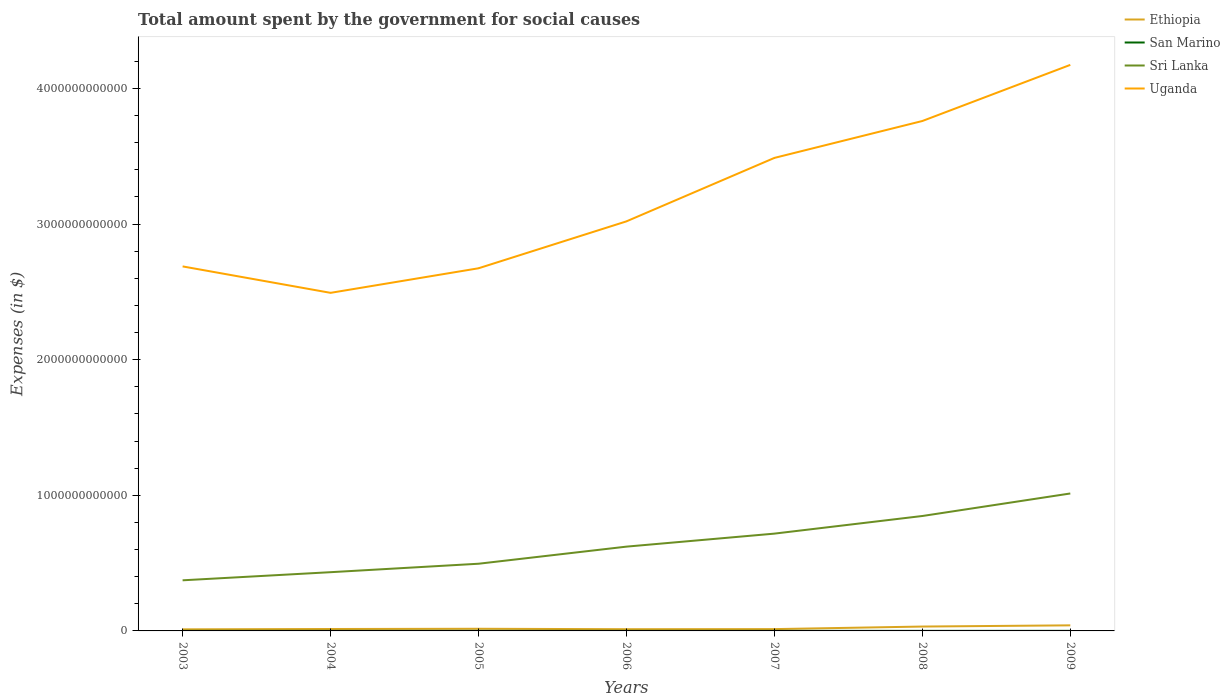Does the line corresponding to Sri Lanka intersect with the line corresponding to Ethiopia?
Give a very brief answer. No. Is the number of lines equal to the number of legend labels?
Provide a succinct answer. Yes. Across all years, what is the maximum amount spent for social causes by the government in Uganda?
Make the answer very short. 2.49e+12. In which year was the amount spent for social causes by the government in San Marino maximum?
Provide a succinct answer. 2003. What is the total amount spent for social causes by the government in Uganda in the graph?
Provide a short and direct response. -1.27e+12. What is the difference between the highest and the second highest amount spent for social causes by the government in Sri Lanka?
Ensure brevity in your answer.  6.40e+11. What is the difference between the highest and the lowest amount spent for social causes by the government in Ethiopia?
Offer a terse response. 2. How many lines are there?
Give a very brief answer. 4. What is the difference between two consecutive major ticks on the Y-axis?
Provide a succinct answer. 1.00e+12. Are the values on the major ticks of Y-axis written in scientific E-notation?
Provide a succinct answer. No. Does the graph contain grids?
Your response must be concise. No. Where does the legend appear in the graph?
Provide a short and direct response. Top right. How many legend labels are there?
Provide a short and direct response. 4. How are the legend labels stacked?
Keep it short and to the point. Vertical. What is the title of the graph?
Keep it short and to the point. Total amount spent by the government for social causes. What is the label or title of the X-axis?
Provide a succinct answer. Years. What is the label or title of the Y-axis?
Your response must be concise. Expenses (in $). What is the Expenses (in $) in Ethiopia in 2003?
Make the answer very short. 1.17e+1. What is the Expenses (in $) in San Marino in 2003?
Your response must be concise. 4.07e+08. What is the Expenses (in $) in Sri Lanka in 2003?
Provide a succinct answer. 3.73e+11. What is the Expenses (in $) of Uganda in 2003?
Give a very brief answer. 2.69e+12. What is the Expenses (in $) in Ethiopia in 2004?
Your answer should be very brief. 1.41e+1. What is the Expenses (in $) in San Marino in 2004?
Keep it short and to the point. 4.59e+08. What is the Expenses (in $) of Sri Lanka in 2004?
Offer a terse response. 4.33e+11. What is the Expenses (in $) of Uganda in 2004?
Provide a short and direct response. 2.49e+12. What is the Expenses (in $) of Ethiopia in 2005?
Provide a succinct answer. 1.59e+1. What is the Expenses (in $) of San Marino in 2005?
Offer a terse response. 4.33e+08. What is the Expenses (in $) in Sri Lanka in 2005?
Your response must be concise. 4.95e+11. What is the Expenses (in $) of Uganda in 2005?
Provide a succinct answer. 2.67e+12. What is the Expenses (in $) of Ethiopia in 2006?
Keep it short and to the point. 1.26e+1. What is the Expenses (in $) of San Marino in 2006?
Give a very brief answer. 4.46e+08. What is the Expenses (in $) in Sri Lanka in 2006?
Provide a succinct answer. 6.21e+11. What is the Expenses (in $) of Uganda in 2006?
Your answer should be compact. 3.02e+12. What is the Expenses (in $) in Ethiopia in 2007?
Give a very brief answer. 1.33e+1. What is the Expenses (in $) of San Marino in 2007?
Your answer should be very brief. 4.86e+08. What is the Expenses (in $) of Sri Lanka in 2007?
Provide a succinct answer. 7.17e+11. What is the Expenses (in $) of Uganda in 2007?
Make the answer very short. 3.49e+12. What is the Expenses (in $) of Ethiopia in 2008?
Your response must be concise. 3.22e+1. What is the Expenses (in $) in San Marino in 2008?
Provide a short and direct response. 5.02e+08. What is the Expenses (in $) of Sri Lanka in 2008?
Offer a terse response. 8.47e+11. What is the Expenses (in $) of Uganda in 2008?
Keep it short and to the point. 3.76e+12. What is the Expenses (in $) in Ethiopia in 2009?
Your answer should be very brief. 4.11e+1. What is the Expenses (in $) in San Marino in 2009?
Provide a short and direct response. 5.34e+08. What is the Expenses (in $) in Sri Lanka in 2009?
Your answer should be compact. 1.01e+12. What is the Expenses (in $) in Uganda in 2009?
Your response must be concise. 4.17e+12. Across all years, what is the maximum Expenses (in $) of Ethiopia?
Your response must be concise. 4.11e+1. Across all years, what is the maximum Expenses (in $) in San Marino?
Offer a terse response. 5.34e+08. Across all years, what is the maximum Expenses (in $) in Sri Lanka?
Your response must be concise. 1.01e+12. Across all years, what is the maximum Expenses (in $) of Uganda?
Your response must be concise. 4.17e+12. Across all years, what is the minimum Expenses (in $) of Ethiopia?
Make the answer very short. 1.17e+1. Across all years, what is the minimum Expenses (in $) in San Marino?
Your answer should be very brief. 4.07e+08. Across all years, what is the minimum Expenses (in $) in Sri Lanka?
Give a very brief answer. 3.73e+11. Across all years, what is the minimum Expenses (in $) of Uganda?
Make the answer very short. 2.49e+12. What is the total Expenses (in $) of Ethiopia in the graph?
Ensure brevity in your answer.  1.41e+11. What is the total Expenses (in $) in San Marino in the graph?
Offer a very short reply. 3.27e+09. What is the total Expenses (in $) in Sri Lanka in the graph?
Give a very brief answer. 4.50e+12. What is the total Expenses (in $) of Uganda in the graph?
Provide a succinct answer. 2.23e+13. What is the difference between the Expenses (in $) in Ethiopia in 2003 and that in 2004?
Your answer should be compact. -2.45e+09. What is the difference between the Expenses (in $) in San Marino in 2003 and that in 2004?
Offer a terse response. -5.16e+07. What is the difference between the Expenses (in $) of Sri Lanka in 2003 and that in 2004?
Offer a terse response. -5.98e+1. What is the difference between the Expenses (in $) of Uganda in 2003 and that in 2004?
Give a very brief answer. 1.95e+11. What is the difference between the Expenses (in $) of Ethiopia in 2003 and that in 2005?
Your answer should be compact. -4.27e+09. What is the difference between the Expenses (in $) of San Marino in 2003 and that in 2005?
Offer a very short reply. -2.59e+07. What is the difference between the Expenses (in $) of Sri Lanka in 2003 and that in 2005?
Your answer should be compact. -1.22e+11. What is the difference between the Expenses (in $) in Uganda in 2003 and that in 2005?
Your answer should be very brief. 1.39e+1. What is the difference between the Expenses (in $) in Ethiopia in 2003 and that in 2006?
Make the answer very short. -9.59e+08. What is the difference between the Expenses (in $) in San Marino in 2003 and that in 2006?
Provide a short and direct response. -3.85e+07. What is the difference between the Expenses (in $) of Sri Lanka in 2003 and that in 2006?
Offer a very short reply. -2.48e+11. What is the difference between the Expenses (in $) of Uganda in 2003 and that in 2006?
Offer a terse response. -3.32e+11. What is the difference between the Expenses (in $) of Ethiopia in 2003 and that in 2007?
Provide a short and direct response. -1.67e+09. What is the difference between the Expenses (in $) of San Marino in 2003 and that in 2007?
Make the answer very short. -7.90e+07. What is the difference between the Expenses (in $) of Sri Lanka in 2003 and that in 2007?
Keep it short and to the point. -3.44e+11. What is the difference between the Expenses (in $) in Uganda in 2003 and that in 2007?
Provide a succinct answer. -8.00e+11. What is the difference between the Expenses (in $) of Ethiopia in 2003 and that in 2008?
Your response must be concise. -2.06e+1. What is the difference between the Expenses (in $) in San Marino in 2003 and that in 2008?
Ensure brevity in your answer.  -9.46e+07. What is the difference between the Expenses (in $) of Sri Lanka in 2003 and that in 2008?
Provide a succinct answer. -4.74e+11. What is the difference between the Expenses (in $) in Uganda in 2003 and that in 2008?
Keep it short and to the point. -1.07e+12. What is the difference between the Expenses (in $) of Ethiopia in 2003 and that in 2009?
Give a very brief answer. -2.94e+1. What is the difference between the Expenses (in $) of San Marino in 2003 and that in 2009?
Keep it short and to the point. -1.27e+08. What is the difference between the Expenses (in $) in Sri Lanka in 2003 and that in 2009?
Your answer should be compact. -6.40e+11. What is the difference between the Expenses (in $) in Uganda in 2003 and that in 2009?
Make the answer very short. -1.49e+12. What is the difference between the Expenses (in $) in Ethiopia in 2004 and that in 2005?
Your answer should be compact. -1.82e+09. What is the difference between the Expenses (in $) of San Marino in 2004 and that in 2005?
Your response must be concise. 2.57e+07. What is the difference between the Expenses (in $) in Sri Lanka in 2004 and that in 2005?
Provide a succinct answer. -6.23e+1. What is the difference between the Expenses (in $) of Uganda in 2004 and that in 2005?
Offer a very short reply. -1.81e+11. What is the difference between the Expenses (in $) of Ethiopia in 2004 and that in 2006?
Provide a short and direct response. 1.50e+09. What is the difference between the Expenses (in $) in San Marino in 2004 and that in 2006?
Offer a terse response. 1.31e+07. What is the difference between the Expenses (in $) in Sri Lanka in 2004 and that in 2006?
Make the answer very short. -1.88e+11. What is the difference between the Expenses (in $) in Uganda in 2004 and that in 2006?
Give a very brief answer. -5.27e+11. What is the difference between the Expenses (in $) in Ethiopia in 2004 and that in 2007?
Give a very brief answer. 7.85e+08. What is the difference between the Expenses (in $) in San Marino in 2004 and that in 2007?
Your answer should be compact. -2.74e+07. What is the difference between the Expenses (in $) in Sri Lanka in 2004 and that in 2007?
Ensure brevity in your answer.  -2.84e+11. What is the difference between the Expenses (in $) in Uganda in 2004 and that in 2007?
Give a very brief answer. -9.95e+11. What is the difference between the Expenses (in $) of Ethiopia in 2004 and that in 2008?
Ensure brevity in your answer.  -1.81e+1. What is the difference between the Expenses (in $) in San Marino in 2004 and that in 2008?
Give a very brief answer. -4.31e+07. What is the difference between the Expenses (in $) in Sri Lanka in 2004 and that in 2008?
Your answer should be compact. -4.14e+11. What is the difference between the Expenses (in $) in Uganda in 2004 and that in 2008?
Offer a very short reply. -1.27e+12. What is the difference between the Expenses (in $) of Ethiopia in 2004 and that in 2009?
Provide a short and direct response. -2.70e+1. What is the difference between the Expenses (in $) of San Marino in 2004 and that in 2009?
Your answer should be compact. -7.51e+07. What is the difference between the Expenses (in $) in Sri Lanka in 2004 and that in 2009?
Your response must be concise. -5.80e+11. What is the difference between the Expenses (in $) of Uganda in 2004 and that in 2009?
Your response must be concise. -1.68e+12. What is the difference between the Expenses (in $) of Ethiopia in 2005 and that in 2006?
Give a very brief answer. 3.31e+09. What is the difference between the Expenses (in $) in San Marino in 2005 and that in 2006?
Keep it short and to the point. -1.26e+07. What is the difference between the Expenses (in $) in Sri Lanka in 2005 and that in 2006?
Make the answer very short. -1.26e+11. What is the difference between the Expenses (in $) of Uganda in 2005 and that in 2006?
Give a very brief answer. -3.46e+11. What is the difference between the Expenses (in $) in Ethiopia in 2005 and that in 2007?
Your answer should be compact. 2.60e+09. What is the difference between the Expenses (in $) of San Marino in 2005 and that in 2007?
Give a very brief answer. -5.31e+07. What is the difference between the Expenses (in $) in Sri Lanka in 2005 and that in 2007?
Provide a short and direct response. -2.22e+11. What is the difference between the Expenses (in $) of Uganda in 2005 and that in 2007?
Your answer should be compact. -8.14e+11. What is the difference between the Expenses (in $) of Ethiopia in 2005 and that in 2008?
Your answer should be compact. -1.63e+1. What is the difference between the Expenses (in $) in San Marino in 2005 and that in 2008?
Give a very brief answer. -6.88e+07. What is the difference between the Expenses (in $) in Sri Lanka in 2005 and that in 2008?
Provide a short and direct response. -3.52e+11. What is the difference between the Expenses (in $) in Uganda in 2005 and that in 2008?
Offer a very short reply. -1.09e+12. What is the difference between the Expenses (in $) of Ethiopia in 2005 and that in 2009?
Give a very brief answer. -2.51e+1. What is the difference between the Expenses (in $) in San Marino in 2005 and that in 2009?
Provide a short and direct response. -1.01e+08. What is the difference between the Expenses (in $) in Sri Lanka in 2005 and that in 2009?
Provide a succinct answer. -5.18e+11. What is the difference between the Expenses (in $) of Uganda in 2005 and that in 2009?
Your response must be concise. -1.50e+12. What is the difference between the Expenses (in $) of Ethiopia in 2006 and that in 2007?
Ensure brevity in your answer.  -7.10e+08. What is the difference between the Expenses (in $) in San Marino in 2006 and that in 2007?
Give a very brief answer. -4.05e+07. What is the difference between the Expenses (in $) in Sri Lanka in 2006 and that in 2007?
Offer a very short reply. -9.59e+1. What is the difference between the Expenses (in $) in Uganda in 2006 and that in 2007?
Ensure brevity in your answer.  -4.68e+11. What is the difference between the Expenses (in $) of Ethiopia in 2006 and that in 2008?
Provide a short and direct response. -1.96e+1. What is the difference between the Expenses (in $) of San Marino in 2006 and that in 2008?
Keep it short and to the point. -5.62e+07. What is the difference between the Expenses (in $) in Sri Lanka in 2006 and that in 2008?
Keep it short and to the point. -2.26e+11. What is the difference between the Expenses (in $) in Uganda in 2006 and that in 2008?
Give a very brief answer. -7.40e+11. What is the difference between the Expenses (in $) in Ethiopia in 2006 and that in 2009?
Make the answer very short. -2.85e+1. What is the difference between the Expenses (in $) in San Marino in 2006 and that in 2009?
Your response must be concise. -8.82e+07. What is the difference between the Expenses (in $) in Sri Lanka in 2006 and that in 2009?
Provide a succinct answer. -3.92e+11. What is the difference between the Expenses (in $) of Uganda in 2006 and that in 2009?
Ensure brevity in your answer.  -1.15e+12. What is the difference between the Expenses (in $) of Ethiopia in 2007 and that in 2008?
Provide a succinct answer. -1.89e+1. What is the difference between the Expenses (in $) of San Marino in 2007 and that in 2008?
Provide a short and direct response. -1.57e+07. What is the difference between the Expenses (in $) of Sri Lanka in 2007 and that in 2008?
Offer a very short reply. -1.30e+11. What is the difference between the Expenses (in $) in Uganda in 2007 and that in 2008?
Make the answer very short. -2.72e+11. What is the difference between the Expenses (in $) in Ethiopia in 2007 and that in 2009?
Provide a short and direct response. -2.77e+1. What is the difference between the Expenses (in $) of San Marino in 2007 and that in 2009?
Your answer should be very brief. -4.77e+07. What is the difference between the Expenses (in $) of Sri Lanka in 2007 and that in 2009?
Your response must be concise. -2.96e+11. What is the difference between the Expenses (in $) in Uganda in 2007 and that in 2009?
Ensure brevity in your answer.  -6.86e+11. What is the difference between the Expenses (in $) of Ethiopia in 2008 and that in 2009?
Give a very brief answer. -8.85e+09. What is the difference between the Expenses (in $) in San Marino in 2008 and that in 2009?
Provide a succinct answer. -3.20e+07. What is the difference between the Expenses (in $) of Sri Lanka in 2008 and that in 2009?
Provide a succinct answer. -1.66e+11. What is the difference between the Expenses (in $) in Uganda in 2008 and that in 2009?
Give a very brief answer. -4.14e+11. What is the difference between the Expenses (in $) of Ethiopia in 2003 and the Expenses (in $) of San Marino in 2004?
Offer a terse response. 1.12e+1. What is the difference between the Expenses (in $) in Ethiopia in 2003 and the Expenses (in $) in Sri Lanka in 2004?
Your answer should be very brief. -4.21e+11. What is the difference between the Expenses (in $) in Ethiopia in 2003 and the Expenses (in $) in Uganda in 2004?
Your answer should be very brief. -2.48e+12. What is the difference between the Expenses (in $) of San Marino in 2003 and the Expenses (in $) of Sri Lanka in 2004?
Offer a terse response. -4.33e+11. What is the difference between the Expenses (in $) in San Marino in 2003 and the Expenses (in $) in Uganda in 2004?
Give a very brief answer. -2.49e+12. What is the difference between the Expenses (in $) of Sri Lanka in 2003 and the Expenses (in $) of Uganda in 2004?
Your response must be concise. -2.12e+12. What is the difference between the Expenses (in $) in Ethiopia in 2003 and the Expenses (in $) in San Marino in 2005?
Provide a short and direct response. 1.12e+1. What is the difference between the Expenses (in $) in Ethiopia in 2003 and the Expenses (in $) in Sri Lanka in 2005?
Provide a succinct answer. -4.84e+11. What is the difference between the Expenses (in $) of Ethiopia in 2003 and the Expenses (in $) of Uganda in 2005?
Offer a very short reply. -2.66e+12. What is the difference between the Expenses (in $) of San Marino in 2003 and the Expenses (in $) of Sri Lanka in 2005?
Your answer should be compact. -4.95e+11. What is the difference between the Expenses (in $) of San Marino in 2003 and the Expenses (in $) of Uganda in 2005?
Ensure brevity in your answer.  -2.67e+12. What is the difference between the Expenses (in $) in Sri Lanka in 2003 and the Expenses (in $) in Uganda in 2005?
Offer a terse response. -2.30e+12. What is the difference between the Expenses (in $) of Ethiopia in 2003 and the Expenses (in $) of San Marino in 2006?
Your answer should be very brief. 1.12e+1. What is the difference between the Expenses (in $) of Ethiopia in 2003 and the Expenses (in $) of Sri Lanka in 2006?
Provide a short and direct response. -6.10e+11. What is the difference between the Expenses (in $) of Ethiopia in 2003 and the Expenses (in $) of Uganda in 2006?
Provide a succinct answer. -3.01e+12. What is the difference between the Expenses (in $) of San Marino in 2003 and the Expenses (in $) of Sri Lanka in 2006?
Keep it short and to the point. -6.21e+11. What is the difference between the Expenses (in $) in San Marino in 2003 and the Expenses (in $) in Uganda in 2006?
Your answer should be compact. -3.02e+12. What is the difference between the Expenses (in $) of Sri Lanka in 2003 and the Expenses (in $) of Uganda in 2006?
Provide a succinct answer. -2.65e+12. What is the difference between the Expenses (in $) of Ethiopia in 2003 and the Expenses (in $) of San Marino in 2007?
Make the answer very short. 1.12e+1. What is the difference between the Expenses (in $) of Ethiopia in 2003 and the Expenses (in $) of Sri Lanka in 2007?
Keep it short and to the point. -7.06e+11. What is the difference between the Expenses (in $) of Ethiopia in 2003 and the Expenses (in $) of Uganda in 2007?
Provide a succinct answer. -3.48e+12. What is the difference between the Expenses (in $) in San Marino in 2003 and the Expenses (in $) in Sri Lanka in 2007?
Keep it short and to the point. -7.17e+11. What is the difference between the Expenses (in $) in San Marino in 2003 and the Expenses (in $) in Uganda in 2007?
Keep it short and to the point. -3.49e+12. What is the difference between the Expenses (in $) in Sri Lanka in 2003 and the Expenses (in $) in Uganda in 2007?
Give a very brief answer. -3.11e+12. What is the difference between the Expenses (in $) of Ethiopia in 2003 and the Expenses (in $) of San Marino in 2008?
Give a very brief answer. 1.12e+1. What is the difference between the Expenses (in $) in Ethiopia in 2003 and the Expenses (in $) in Sri Lanka in 2008?
Keep it short and to the point. -8.36e+11. What is the difference between the Expenses (in $) in Ethiopia in 2003 and the Expenses (in $) in Uganda in 2008?
Offer a very short reply. -3.75e+12. What is the difference between the Expenses (in $) in San Marino in 2003 and the Expenses (in $) in Sri Lanka in 2008?
Your answer should be compact. -8.47e+11. What is the difference between the Expenses (in $) of San Marino in 2003 and the Expenses (in $) of Uganda in 2008?
Offer a very short reply. -3.76e+12. What is the difference between the Expenses (in $) in Sri Lanka in 2003 and the Expenses (in $) in Uganda in 2008?
Keep it short and to the point. -3.39e+12. What is the difference between the Expenses (in $) in Ethiopia in 2003 and the Expenses (in $) in San Marino in 2009?
Offer a very short reply. 1.11e+1. What is the difference between the Expenses (in $) of Ethiopia in 2003 and the Expenses (in $) of Sri Lanka in 2009?
Your response must be concise. -1.00e+12. What is the difference between the Expenses (in $) in Ethiopia in 2003 and the Expenses (in $) in Uganda in 2009?
Provide a succinct answer. -4.16e+12. What is the difference between the Expenses (in $) of San Marino in 2003 and the Expenses (in $) of Sri Lanka in 2009?
Ensure brevity in your answer.  -1.01e+12. What is the difference between the Expenses (in $) of San Marino in 2003 and the Expenses (in $) of Uganda in 2009?
Your response must be concise. -4.17e+12. What is the difference between the Expenses (in $) in Sri Lanka in 2003 and the Expenses (in $) in Uganda in 2009?
Provide a short and direct response. -3.80e+12. What is the difference between the Expenses (in $) of Ethiopia in 2004 and the Expenses (in $) of San Marino in 2005?
Offer a very short reply. 1.37e+1. What is the difference between the Expenses (in $) in Ethiopia in 2004 and the Expenses (in $) in Sri Lanka in 2005?
Your response must be concise. -4.81e+11. What is the difference between the Expenses (in $) of Ethiopia in 2004 and the Expenses (in $) of Uganda in 2005?
Keep it short and to the point. -2.66e+12. What is the difference between the Expenses (in $) of San Marino in 2004 and the Expenses (in $) of Sri Lanka in 2005?
Your answer should be compact. -4.95e+11. What is the difference between the Expenses (in $) in San Marino in 2004 and the Expenses (in $) in Uganda in 2005?
Provide a succinct answer. -2.67e+12. What is the difference between the Expenses (in $) of Sri Lanka in 2004 and the Expenses (in $) of Uganda in 2005?
Keep it short and to the point. -2.24e+12. What is the difference between the Expenses (in $) of Ethiopia in 2004 and the Expenses (in $) of San Marino in 2006?
Ensure brevity in your answer.  1.37e+1. What is the difference between the Expenses (in $) of Ethiopia in 2004 and the Expenses (in $) of Sri Lanka in 2006?
Offer a very short reply. -6.07e+11. What is the difference between the Expenses (in $) of Ethiopia in 2004 and the Expenses (in $) of Uganda in 2006?
Provide a succinct answer. -3.01e+12. What is the difference between the Expenses (in $) in San Marino in 2004 and the Expenses (in $) in Sri Lanka in 2006?
Give a very brief answer. -6.21e+11. What is the difference between the Expenses (in $) of San Marino in 2004 and the Expenses (in $) of Uganda in 2006?
Ensure brevity in your answer.  -3.02e+12. What is the difference between the Expenses (in $) in Sri Lanka in 2004 and the Expenses (in $) in Uganda in 2006?
Your answer should be compact. -2.59e+12. What is the difference between the Expenses (in $) of Ethiopia in 2004 and the Expenses (in $) of San Marino in 2007?
Ensure brevity in your answer.  1.36e+1. What is the difference between the Expenses (in $) in Ethiopia in 2004 and the Expenses (in $) in Sri Lanka in 2007?
Your response must be concise. -7.03e+11. What is the difference between the Expenses (in $) in Ethiopia in 2004 and the Expenses (in $) in Uganda in 2007?
Your answer should be very brief. -3.47e+12. What is the difference between the Expenses (in $) of San Marino in 2004 and the Expenses (in $) of Sri Lanka in 2007?
Keep it short and to the point. -7.17e+11. What is the difference between the Expenses (in $) of San Marino in 2004 and the Expenses (in $) of Uganda in 2007?
Your response must be concise. -3.49e+12. What is the difference between the Expenses (in $) in Sri Lanka in 2004 and the Expenses (in $) in Uganda in 2007?
Ensure brevity in your answer.  -3.05e+12. What is the difference between the Expenses (in $) of Ethiopia in 2004 and the Expenses (in $) of San Marino in 2008?
Ensure brevity in your answer.  1.36e+1. What is the difference between the Expenses (in $) in Ethiopia in 2004 and the Expenses (in $) in Sri Lanka in 2008?
Offer a very short reply. -8.33e+11. What is the difference between the Expenses (in $) in Ethiopia in 2004 and the Expenses (in $) in Uganda in 2008?
Offer a very short reply. -3.75e+12. What is the difference between the Expenses (in $) in San Marino in 2004 and the Expenses (in $) in Sri Lanka in 2008?
Your answer should be very brief. -8.47e+11. What is the difference between the Expenses (in $) of San Marino in 2004 and the Expenses (in $) of Uganda in 2008?
Your answer should be very brief. -3.76e+12. What is the difference between the Expenses (in $) of Sri Lanka in 2004 and the Expenses (in $) of Uganda in 2008?
Give a very brief answer. -3.33e+12. What is the difference between the Expenses (in $) of Ethiopia in 2004 and the Expenses (in $) of San Marino in 2009?
Your response must be concise. 1.36e+1. What is the difference between the Expenses (in $) of Ethiopia in 2004 and the Expenses (in $) of Sri Lanka in 2009?
Keep it short and to the point. -9.99e+11. What is the difference between the Expenses (in $) of Ethiopia in 2004 and the Expenses (in $) of Uganda in 2009?
Make the answer very short. -4.16e+12. What is the difference between the Expenses (in $) in San Marino in 2004 and the Expenses (in $) in Sri Lanka in 2009?
Provide a succinct answer. -1.01e+12. What is the difference between the Expenses (in $) of San Marino in 2004 and the Expenses (in $) of Uganda in 2009?
Offer a very short reply. -4.17e+12. What is the difference between the Expenses (in $) in Sri Lanka in 2004 and the Expenses (in $) in Uganda in 2009?
Make the answer very short. -3.74e+12. What is the difference between the Expenses (in $) in Ethiopia in 2005 and the Expenses (in $) in San Marino in 2006?
Provide a short and direct response. 1.55e+1. What is the difference between the Expenses (in $) of Ethiopia in 2005 and the Expenses (in $) of Sri Lanka in 2006?
Offer a very short reply. -6.06e+11. What is the difference between the Expenses (in $) of Ethiopia in 2005 and the Expenses (in $) of Uganda in 2006?
Your answer should be compact. -3.00e+12. What is the difference between the Expenses (in $) of San Marino in 2005 and the Expenses (in $) of Sri Lanka in 2006?
Provide a succinct answer. -6.21e+11. What is the difference between the Expenses (in $) of San Marino in 2005 and the Expenses (in $) of Uganda in 2006?
Make the answer very short. -3.02e+12. What is the difference between the Expenses (in $) of Sri Lanka in 2005 and the Expenses (in $) of Uganda in 2006?
Your answer should be compact. -2.52e+12. What is the difference between the Expenses (in $) of Ethiopia in 2005 and the Expenses (in $) of San Marino in 2007?
Your answer should be compact. 1.54e+1. What is the difference between the Expenses (in $) in Ethiopia in 2005 and the Expenses (in $) in Sri Lanka in 2007?
Provide a short and direct response. -7.01e+11. What is the difference between the Expenses (in $) of Ethiopia in 2005 and the Expenses (in $) of Uganda in 2007?
Offer a very short reply. -3.47e+12. What is the difference between the Expenses (in $) of San Marino in 2005 and the Expenses (in $) of Sri Lanka in 2007?
Your answer should be very brief. -7.17e+11. What is the difference between the Expenses (in $) in San Marino in 2005 and the Expenses (in $) in Uganda in 2007?
Your answer should be very brief. -3.49e+12. What is the difference between the Expenses (in $) in Sri Lanka in 2005 and the Expenses (in $) in Uganda in 2007?
Keep it short and to the point. -2.99e+12. What is the difference between the Expenses (in $) of Ethiopia in 2005 and the Expenses (in $) of San Marino in 2008?
Offer a very short reply. 1.54e+1. What is the difference between the Expenses (in $) of Ethiopia in 2005 and the Expenses (in $) of Sri Lanka in 2008?
Keep it short and to the point. -8.31e+11. What is the difference between the Expenses (in $) of Ethiopia in 2005 and the Expenses (in $) of Uganda in 2008?
Keep it short and to the point. -3.74e+12. What is the difference between the Expenses (in $) of San Marino in 2005 and the Expenses (in $) of Sri Lanka in 2008?
Provide a short and direct response. -8.47e+11. What is the difference between the Expenses (in $) in San Marino in 2005 and the Expenses (in $) in Uganda in 2008?
Keep it short and to the point. -3.76e+12. What is the difference between the Expenses (in $) of Sri Lanka in 2005 and the Expenses (in $) of Uganda in 2008?
Provide a succinct answer. -3.26e+12. What is the difference between the Expenses (in $) in Ethiopia in 2005 and the Expenses (in $) in San Marino in 2009?
Ensure brevity in your answer.  1.54e+1. What is the difference between the Expenses (in $) of Ethiopia in 2005 and the Expenses (in $) of Sri Lanka in 2009?
Your answer should be very brief. -9.97e+11. What is the difference between the Expenses (in $) in Ethiopia in 2005 and the Expenses (in $) in Uganda in 2009?
Ensure brevity in your answer.  -4.16e+12. What is the difference between the Expenses (in $) in San Marino in 2005 and the Expenses (in $) in Sri Lanka in 2009?
Offer a very short reply. -1.01e+12. What is the difference between the Expenses (in $) of San Marino in 2005 and the Expenses (in $) of Uganda in 2009?
Your answer should be compact. -4.17e+12. What is the difference between the Expenses (in $) in Sri Lanka in 2005 and the Expenses (in $) in Uganda in 2009?
Ensure brevity in your answer.  -3.68e+12. What is the difference between the Expenses (in $) of Ethiopia in 2006 and the Expenses (in $) of San Marino in 2007?
Offer a terse response. 1.21e+1. What is the difference between the Expenses (in $) in Ethiopia in 2006 and the Expenses (in $) in Sri Lanka in 2007?
Offer a very short reply. -7.05e+11. What is the difference between the Expenses (in $) in Ethiopia in 2006 and the Expenses (in $) in Uganda in 2007?
Offer a terse response. -3.48e+12. What is the difference between the Expenses (in $) of San Marino in 2006 and the Expenses (in $) of Sri Lanka in 2007?
Your answer should be compact. -7.17e+11. What is the difference between the Expenses (in $) of San Marino in 2006 and the Expenses (in $) of Uganda in 2007?
Offer a terse response. -3.49e+12. What is the difference between the Expenses (in $) of Sri Lanka in 2006 and the Expenses (in $) of Uganda in 2007?
Offer a very short reply. -2.87e+12. What is the difference between the Expenses (in $) of Ethiopia in 2006 and the Expenses (in $) of San Marino in 2008?
Offer a very short reply. 1.21e+1. What is the difference between the Expenses (in $) of Ethiopia in 2006 and the Expenses (in $) of Sri Lanka in 2008?
Your answer should be very brief. -8.35e+11. What is the difference between the Expenses (in $) in Ethiopia in 2006 and the Expenses (in $) in Uganda in 2008?
Offer a terse response. -3.75e+12. What is the difference between the Expenses (in $) in San Marino in 2006 and the Expenses (in $) in Sri Lanka in 2008?
Provide a short and direct response. -8.47e+11. What is the difference between the Expenses (in $) in San Marino in 2006 and the Expenses (in $) in Uganda in 2008?
Make the answer very short. -3.76e+12. What is the difference between the Expenses (in $) in Sri Lanka in 2006 and the Expenses (in $) in Uganda in 2008?
Give a very brief answer. -3.14e+12. What is the difference between the Expenses (in $) of Ethiopia in 2006 and the Expenses (in $) of San Marino in 2009?
Your response must be concise. 1.21e+1. What is the difference between the Expenses (in $) of Ethiopia in 2006 and the Expenses (in $) of Sri Lanka in 2009?
Your response must be concise. -1.00e+12. What is the difference between the Expenses (in $) of Ethiopia in 2006 and the Expenses (in $) of Uganda in 2009?
Your answer should be very brief. -4.16e+12. What is the difference between the Expenses (in $) in San Marino in 2006 and the Expenses (in $) in Sri Lanka in 2009?
Make the answer very short. -1.01e+12. What is the difference between the Expenses (in $) of San Marino in 2006 and the Expenses (in $) of Uganda in 2009?
Provide a short and direct response. -4.17e+12. What is the difference between the Expenses (in $) in Sri Lanka in 2006 and the Expenses (in $) in Uganda in 2009?
Make the answer very short. -3.55e+12. What is the difference between the Expenses (in $) in Ethiopia in 2007 and the Expenses (in $) in San Marino in 2008?
Make the answer very short. 1.28e+1. What is the difference between the Expenses (in $) of Ethiopia in 2007 and the Expenses (in $) of Sri Lanka in 2008?
Your answer should be very brief. -8.34e+11. What is the difference between the Expenses (in $) in Ethiopia in 2007 and the Expenses (in $) in Uganda in 2008?
Provide a succinct answer. -3.75e+12. What is the difference between the Expenses (in $) of San Marino in 2007 and the Expenses (in $) of Sri Lanka in 2008?
Ensure brevity in your answer.  -8.47e+11. What is the difference between the Expenses (in $) in San Marino in 2007 and the Expenses (in $) in Uganda in 2008?
Your answer should be compact. -3.76e+12. What is the difference between the Expenses (in $) of Sri Lanka in 2007 and the Expenses (in $) of Uganda in 2008?
Provide a succinct answer. -3.04e+12. What is the difference between the Expenses (in $) of Ethiopia in 2007 and the Expenses (in $) of San Marino in 2009?
Give a very brief answer. 1.28e+1. What is the difference between the Expenses (in $) of Ethiopia in 2007 and the Expenses (in $) of Sri Lanka in 2009?
Provide a succinct answer. -1.00e+12. What is the difference between the Expenses (in $) in Ethiopia in 2007 and the Expenses (in $) in Uganda in 2009?
Keep it short and to the point. -4.16e+12. What is the difference between the Expenses (in $) in San Marino in 2007 and the Expenses (in $) in Sri Lanka in 2009?
Keep it short and to the point. -1.01e+12. What is the difference between the Expenses (in $) in San Marino in 2007 and the Expenses (in $) in Uganda in 2009?
Your answer should be compact. -4.17e+12. What is the difference between the Expenses (in $) of Sri Lanka in 2007 and the Expenses (in $) of Uganda in 2009?
Provide a succinct answer. -3.46e+12. What is the difference between the Expenses (in $) in Ethiopia in 2008 and the Expenses (in $) in San Marino in 2009?
Ensure brevity in your answer.  3.17e+1. What is the difference between the Expenses (in $) of Ethiopia in 2008 and the Expenses (in $) of Sri Lanka in 2009?
Provide a short and direct response. -9.81e+11. What is the difference between the Expenses (in $) of Ethiopia in 2008 and the Expenses (in $) of Uganda in 2009?
Your answer should be very brief. -4.14e+12. What is the difference between the Expenses (in $) of San Marino in 2008 and the Expenses (in $) of Sri Lanka in 2009?
Give a very brief answer. -1.01e+12. What is the difference between the Expenses (in $) in San Marino in 2008 and the Expenses (in $) in Uganda in 2009?
Your response must be concise. -4.17e+12. What is the difference between the Expenses (in $) in Sri Lanka in 2008 and the Expenses (in $) in Uganda in 2009?
Offer a very short reply. -3.33e+12. What is the average Expenses (in $) in Ethiopia per year?
Keep it short and to the point. 2.01e+1. What is the average Expenses (in $) of San Marino per year?
Offer a terse response. 4.67e+08. What is the average Expenses (in $) in Sri Lanka per year?
Your answer should be very brief. 6.43e+11. What is the average Expenses (in $) of Uganda per year?
Offer a terse response. 3.19e+12. In the year 2003, what is the difference between the Expenses (in $) of Ethiopia and Expenses (in $) of San Marino?
Give a very brief answer. 1.13e+1. In the year 2003, what is the difference between the Expenses (in $) of Ethiopia and Expenses (in $) of Sri Lanka?
Give a very brief answer. -3.62e+11. In the year 2003, what is the difference between the Expenses (in $) of Ethiopia and Expenses (in $) of Uganda?
Make the answer very short. -2.68e+12. In the year 2003, what is the difference between the Expenses (in $) of San Marino and Expenses (in $) of Sri Lanka?
Offer a terse response. -3.73e+11. In the year 2003, what is the difference between the Expenses (in $) of San Marino and Expenses (in $) of Uganda?
Your response must be concise. -2.69e+12. In the year 2003, what is the difference between the Expenses (in $) in Sri Lanka and Expenses (in $) in Uganda?
Your answer should be very brief. -2.31e+12. In the year 2004, what is the difference between the Expenses (in $) of Ethiopia and Expenses (in $) of San Marino?
Make the answer very short. 1.37e+1. In the year 2004, what is the difference between the Expenses (in $) of Ethiopia and Expenses (in $) of Sri Lanka?
Your answer should be very brief. -4.19e+11. In the year 2004, what is the difference between the Expenses (in $) in Ethiopia and Expenses (in $) in Uganda?
Make the answer very short. -2.48e+12. In the year 2004, what is the difference between the Expenses (in $) of San Marino and Expenses (in $) of Sri Lanka?
Your answer should be very brief. -4.33e+11. In the year 2004, what is the difference between the Expenses (in $) in San Marino and Expenses (in $) in Uganda?
Provide a short and direct response. -2.49e+12. In the year 2004, what is the difference between the Expenses (in $) of Sri Lanka and Expenses (in $) of Uganda?
Offer a terse response. -2.06e+12. In the year 2005, what is the difference between the Expenses (in $) of Ethiopia and Expenses (in $) of San Marino?
Your response must be concise. 1.55e+1. In the year 2005, what is the difference between the Expenses (in $) of Ethiopia and Expenses (in $) of Sri Lanka?
Your answer should be compact. -4.79e+11. In the year 2005, what is the difference between the Expenses (in $) of Ethiopia and Expenses (in $) of Uganda?
Provide a succinct answer. -2.66e+12. In the year 2005, what is the difference between the Expenses (in $) of San Marino and Expenses (in $) of Sri Lanka?
Your answer should be very brief. -4.95e+11. In the year 2005, what is the difference between the Expenses (in $) in San Marino and Expenses (in $) in Uganda?
Offer a terse response. -2.67e+12. In the year 2005, what is the difference between the Expenses (in $) in Sri Lanka and Expenses (in $) in Uganda?
Your answer should be compact. -2.18e+12. In the year 2006, what is the difference between the Expenses (in $) of Ethiopia and Expenses (in $) of San Marino?
Offer a terse response. 1.22e+1. In the year 2006, what is the difference between the Expenses (in $) of Ethiopia and Expenses (in $) of Sri Lanka?
Ensure brevity in your answer.  -6.09e+11. In the year 2006, what is the difference between the Expenses (in $) in Ethiopia and Expenses (in $) in Uganda?
Give a very brief answer. -3.01e+12. In the year 2006, what is the difference between the Expenses (in $) of San Marino and Expenses (in $) of Sri Lanka?
Provide a short and direct response. -6.21e+11. In the year 2006, what is the difference between the Expenses (in $) in San Marino and Expenses (in $) in Uganda?
Offer a terse response. -3.02e+12. In the year 2006, what is the difference between the Expenses (in $) in Sri Lanka and Expenses (in $) in Uganda?
Give a very brief answer. -2.40e+12. In the year 2007, what is the difference between the Expenses (in $) of Ethiopia and Expenses (in $) of San Marino?
Make the answer very short. 1.28e+1. In the year 2007, what is the difference between the Expenses (in $) in Ethiopia and Expenses (in $) in Sri Lanka?
Offer a very short reply. -7.04e+11. In the year 2007, what is the difference between the Expenses (in $) in Ethiopia and Expenses (in $) in Uganda?
Keep it short and to the point. -3.47e+12. In the year 2007, what is the difference between the Expenses (in $) of San Marino and Expenses (in $) of Sri Lanka?
Provide a short and direct response. -7.17e+11. In the year 2007, what is the difference between the Expenses (in $) of San Marino and Expenses (in $) of Uganda?
Keep it short and to the point. -3.49e+12. In the year 2007, what is the difference between the Expenses (in $) in Sri Lanka and Expenses (in $) in Uganda?
Ensure brevity in your answer.  -2.77e+12. In the year 2008, what is the difference between the Expenses (in $) of Ethiopia and Expenses (in $) of San Marino?
Make the answer very short. 3.17e+1. In the year 2008, what is the difference between the Expenses (in $) in Ethiopia and Expenses (in $) in Sri Lanka?
Offer a very short reply. -8.15e+11. In the year 2008, what is the difference between the Expenses (in $) in Ethiopia and Expenses (in $) in Uganda?
Your response must be concise. -3.73e+12. In the year 2008, what is the difference between the Expenses (in $) in San Marino and Expenses (in $) in Sri Lanka?
Keep it short and to the point. -8.47e+11. In the year 2008, what is the difference between the Expenses (in $) of San Marino and Expenses (in $) of Uganda?
Provide a short and direct response. -3.76e+12. In the year 2008, what is the difference between the Expenses (in $) of Sri Lanka and Expenses (in $) of Uganda?
Your response must be concise. -2.91e+12. In the year 2009, what is the difference between the Expenses (in $) of Ethiopia and Expenses (in $) of San Marino?
Your answer should be very brief. 4.05e+1. In the year 2009, what is the difference between the Expenses (in $) of Ethiopia and Expenses (in $) of Sri Lanka?
Make the answer very short. -9.72e+11. In the year 2009, what is the difference between the Expenses (in $) of Ethiopia and Expenses (in $) of Uganda?
Keep it short and to the point. -4.13e+12. In the year 2009, what is the difference between the Expenses (in $) in San Marino and Expenses (in $) in Sri Lanka?
Keep it short and to the point. -1.01e+12. In the year 2009, what is the difference between the Expenses (in $) of San Marino and Expenses (in $) of Uganda?
Your response must be concise. -4.17e+12. In the year 2009, what is the difference between the Expenses (in $) of Sri Lanka and Expenses (in $) of Uganda?
Your response must be concise. -3.16e+12. What is the ratio of the Expenses (in $) of Ethiopia in 2003 to that in 2004?
Keep it short and to the point. 0.83. What is the ratio of the Expenses (in $) in San Marino in 2003 to that in 2004?
Make the answer very short. 0.89. What is the ratio of the Expenses (in $) in Sri Lanka in 2003 to that in 2004?
Make the answer very short. 0.86. What is the ratio of the Expenses (in $) in Uganda in 2003 to that in 2004?
Ensure brevity in your answer.  1.08. What is the ratio of the Expenses (in $) in Ethiopia in 2003 to that in 2005?
Keep it short and to the point. 0.73. What is the ratio of the Expenses (in $) in San Marino in 2003 to that in 2005?
Ensure brevity in your answer.  0.94. What is the ratio of the Expenses (in $) of Sri Lanka in 2003 to that in 2005?
Your response must be concise. 0.75. What is the ratio of the Expenses (in $) in Ethiopia in 2003 to that in 2006?
Give a very brief answer. 0.92. What is the ratio of the Expenses (in $) in San Marino in 2003 to that in 2006?
Your response must be concise. 0.91. What is the ratio of the Expenses (in $) in Sri Lanka in 2003 to that in 2006?
Your answer should be compact. 0.6. What is the ratio of the Expenses (in $) in Uganda in 2003 to that in 2006?
Give a very brief answer. 0.89. What is the ratio of the Expenses (in $) of Ethiopia in 2003 to that in 2007?
Provide a short and direct response. 0.87. What is the ratio of the Expenses (in $) in San Marino in 2003 to that in 2007?
Make the answer very short. 0.84. What is the ratio of the Expenses (in $) in Sri Lanka in 2003 to that in 2007?
Provide a short and direct response. 0.52. What is the ratio of the Expenses (in $) of Uganda in 2003 to that in 2007?
Offer a very short reply. 0.77. What is the ratio of the Expenses (in $) of Ethiopia in 2003 to that in 2008?
Your answer should be compact. 0.36. What is the ratio of the Expenses (in $) of San Marino in 2003 to that in 2008?
Offer a terse response. 0.81. What is the ratio of the Expenses (in $) in Sri Lanka in 2003 to that in 2008?
Your answer should be compact. 0.44. What is the ratio of the Expenses (in $) in Uganda in 2003 to that in 2008?
Offer a terse response. 0.71. What is the ratio of the Expenses (in $) of Ethiopia in 2003 to that in 2009?
Give a very brief answer. 0.28. What is the ratio of the Expenses (in $) in San Marino in 2003 to that in 2009?
Your answer should be compact. 0.76. What is the ratio of the Expenses (in $) in Sri Lanka in 2003 to that in 2009?
Make the answer very short. 0.37. What is the ratio of the Expenses (in $) of Uganda in 2003 to that in 2009?
Your response must be concise. 0.64. What is the ratio of the Expenses (in $) in Ethiopia in 2004 to that in 2005?
Your response must be concise. 0.89. What is the ratio of the Expenses (in $) in San Marino in 2004 to that in 2005?
Your answer should be very brief. 1.06. What is the ratio of the Expenses (in $) in Sri Lanka in 2004 to that in 2005?
Offer a very short reply. 0.87. What is the ratio of the Expenses (in $) of Uganda in 2004 to that in 2005?
Give a very brief answer. 0.93. What is the ratio of the Expenses (in $) in Ethiopia in 2004 to that in 2006?
Your answer should be compact. 1.12. What is the ratio of the Expenses (in $) in San Marino in 2004 to that in 2006?
Your response must be concise. 1.03. What is the ratio of the Expenses (in $) in Sri Lanka in 2004 to that in 2006?
Make the answer very short. 0.7. What is the ratio of the Expenses (in $) of Uganda in 2004 to that in 2006?
Keep it short and to the point. 0.83. What is the ratio of the Expenses (in $) of Ethiopia in 2004 to that in 2007?
Give a very brief answer. 1.06. What is the ratio of the Expenses (in $) in San Marino in 2004 to that in 2007?
Your response must be concise. 0.94. What is the ratio of the Expenses (in $) of Sri Lanka in 2004 to that in 2007?
Provide a succinct answer. 0.6. What is the ratio of the Expenses (in $) in Uganda in 2004 to that in 2007?
Ensure brevity in your answer.  0.71. What is the ratio of the Expenses (in $) of Ethiopia in 2004 to that in 2008?
Provide a short and direct response. 0.44. What is the ratio of the Expenses (in $) of San Marino in 2004 to that in 2008?
Your response must be concise. 0.91. What is the ratio of the Expenses (in $) of Sri Lanka in 2004 to that in 2008?
Your answer should be very brief. 0.51. What is the ratio of the Expenses (in $) in Uganda in 2004 to that in 2008?
Provide a succinct answer. 0.66. What is the ratio of the Expenses (in $) in Ethiopia in 2004 to that in 2009?
Offer a very short reply. 0.34. What is the ratio of the Expenses (in $) in San Marino in 2004 to that in 2009?
Your answer should be very brief. 0.86. What is the ratio of the Expenses (in $) in Sri Lanka in 2004 to that in 2009?
Your answer should be very brief. 0.43. What is the ratio of the Expenses (in $) in Uganda in 2004 to that in 2009?
Keep it short and to the point. 0.6. What is the ratio of the Expenses (in $) of Ethiopia in 2005 to that in 2006?
Your answer should be compact. 1.26. What is the ratio of the Expenses (in $) in San Marino in 2005 to that in 2006?
Make the answer very short. 0.97. What is the ratio of the Expenses (in $) of Sri Lanka in 2005 to that in 2006?
Make the answer very short. 0.8. What is the ratio of the Expenses (in $) in Uganda in 2005 to that in 2006?
Your answer should be very brief. 0.89. What is the ratio of the Expenses (in $) in Ethiopia in 2005 to that in 2007?
Keep it short and to the point. 1.2. What is the ratio of the Expenses (in $) in San Marino in 2005 to that in 2007?
Make the answer very short. 0.89. What is the ratio of the Expenses (in $) of Sri Lanka in 2005 to that in 2007?
Give a very brief answer. 0.69. What is the ratio of the Expenses (in $) in Uganda in 2005 to that in 2007?
Ensure brevity in your answer.  0.77. What is the ratio of the Expenses (in $) in Ethiopia in 2005 to that in 2008?
Ensure brevity in your answer.  0.49. What is the ratio of the Expenses (in $) in San Marino in 2005 to that in 2008?
Provide a succinct answer. 0.86. What is the ratio of the Expenses (in $) in Sri Lanka in 2005 to that in 2008?
Provide a succinct answer. 0.58. What is the ratio of the Expenses (in $) of Uganda in 2005 to that in 2008?
Keep it short and to the point. 0.71. What is the ratio of the Expenses (in $) of Ethiopia in 2005 to that in 2009?
Your response must be concise. 0.39. What is the ratio of the Expenses (in $) in San Marino in 2005 to that in 2009?
Provide a succinct answer. 0.81. What is the ratio of the Expenses (in $) of Sri Lanka in 2005 to that in 2009?
Give a very brief answer. 0.49. What is the ratio of the Expenses (in $) in Uganda in 2005 to that in 2009?
Offer a terse response. 0.64. What is the ratio of the Expenses (in $) of Ethiopia in 2006 to that in 2007?
Offer a terse response. 0.95. What is the ratio of the Expenses (in $) of Sri Lanka in 2006 to that in 2007?
Give a very brief answer. 0.87. What is the ratio of the Expenses (in $) in Uganda in 2006 to that in 2007?
Your answer should be compact. 0.87. What is the ratio of the Expenses (in $) in Ethiopia in 2006 to that in 2008?
Make the answer very short. 0.39. What is the ratio of the Expenses (in $) in San Marino in 2006 to that in 2008?
Your response must be concise. 0.89. What is the ratio of the Expenses (in $) of Sri Lanka in 2006 to that in 2008?
Your response must be concise. 0.73. What is the ratio of the Expenses (in $) of Uganda in 2006 to that in 2008?
Ensure brevity in your answer.  0.8. What is the ratio of the Expenses (in $) in Ethiopia in 2006 to that in 2009?
Your response must be concise. 0.31. What is the ratio of the Expenses (in $) in San Marino in 2006 to that in 2009?
Your answer should be very brief. 0.83. What is the ratio of the Expenses (in $) of Sri Lanka in 2006 to that in 2009?
Give a very brief answer. 0.61. What is the ratio of the Expenses (in $) of Uganda in 2006 to that in 2009?
Give a very brief answer. 0.72. What is the ratio of the Expenses (in $) in Ethiopia in 2007 to that in 2008?
Provide a short and direct response. 0.41. What is the ratio of the Expenses (in $) in San Marino in 2007 to that in 2008?
Your response must be concise. 0.97. What is the ratio of the Expenses (in $) of Sri Lanka in 2007 to that in 2008?
Offer a very short reply. 0.85. What is the ratio of the Expenses (in $) in Uganda in 2007 to that in 2008?
Provide a succinct answer. 0.93. What is the ratio of the Expenses (in $) of Ethiopia in 2007 to that in 2009?
Give a very brief answer. 0.32. What is the ratio of the Expenses (in $) in San Marino in 2007 to that in 2009?
Offer a terse response. 0.91. What is the ratio of the Expenses (in $) of Sri Lanka in 2007 to that in 2009?
Make the answer very short. 0.71. What is the ratio of the Expenses (in $) of Uganda in 2007 to that in 2009?
Make the answer very short. 0.84. What is the ratio of the Expenses (in $) in Ethiopia in 2008 to that in 2009?
Provide a succinct answer. 0.78. What is the ratio of the Expenses (in $) of San Marino in 2008 to that in 2009?
Your response must be concise. 0.94. What is the ratio of the Expenses (in $) of Sri Lanka in 2008 to that in 2009?
Your answer should be compact. 0.84. What is the ratio of the Expenses (in $) of Uganda in 2008 to that in 2009?
Keep it short and to the point. 0.9. What is the difference between the highest and the second highest Expenses (in $) of Ethiopia?
Make the answer very short. 8.85e+09. What is the difference between the highest and the second highest Expenses (in $) in San Marino?
Your answer should be compact. 3.20e+07. What is the difference between the highest and the second highest Expenses (in $) in Sri Lanka?
Keep it short and to the point. 1.66e+11. What is the difference between the highest and the second highest Expenses (in $) in Uganda?
Give a very brief answer. 4.14e+11. What is the difference between the highest and the lowest Expenses (in $) of Ethiopia?
Your answer should be very brief. 2.94e+1. What is the difference between the highest and the lowest Expenses (in $) in San Marino?
Offer a very short reply. 1.27e+08. What is the difference between the highest and the lowest Expenses (in $) in Sri Lanka?
Offer a terse response. 6.40e+11. What is the difference between the highest and the lowest Expenses (in $) of Uganda?
Your answer should be compact. 1.68e+12. 